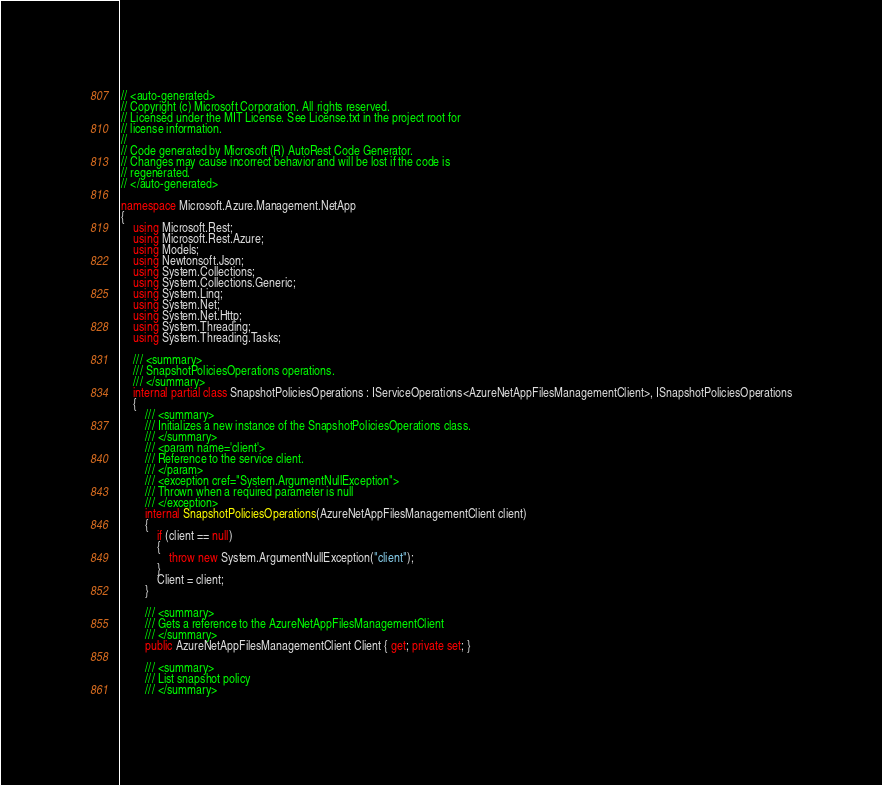Convert code to text. <code><loc_0><loc_0><loc_500><loc_500><_C#_>// <auto-generated>
// Copyright (c) Microsoft Corporation. All rights reserved.
// Licensed under the MIT License. See License.txt in the project root for
// license information.
//
// Code generated by Microsoft (R) AutoRest Code Generator.
// Changes may cause incorrect behavior and will be lost if the code is
// regenerated.
// </auto-generated>

namespace Microsoft.Azure.Management.NetApp
{
    using Microsoft.Rest;
    using Microsoft.Rest.Azure;
    using Models;
    using Newtonsoft.Json;
    using System.Collections;
    using System.Collections.Generic;
    using System.Linq;
    using System.Net;
    using System.Net.Http;
    using System.Threading;
    using System.Threading.Tasks;

    /// <summary>
    /// SnapshotPoliciesOperations operations.
    /// </summary>
    internal partial class SnapshotPoliciesOperations : IServiceOperations<AzureNetAppFilesManagementClient>, ISnapshotPoliciesOperations
    {
        /// <summary>
        /// Initializes a new instance of the SnapshotPoliciesOperations class.
        /// </summary>
        /// <param name='client'>
        /// Reference to the service client.
        /// </param>
        /// <exception cref="System.ArgumentNullException">
        /// Thrown when a required parameter is null
        /// </exception>
        internal SnapshotPoliciesOperations(AzureNetAppFilesManagementClient client)
        {
            if (client == null)
            {
                throw new System.ArgumentNullException("client");
            }
            Client = client;
        }

        /// <summary>
        /// Gets a reference to the AzureNetAppFilesManagementClient
        /// </summary>
        public AzureNetAppFilesManagementClient Client { get; private set; }

        /// <summary>
        /// List snapshot policy
        /// </summary></code> 